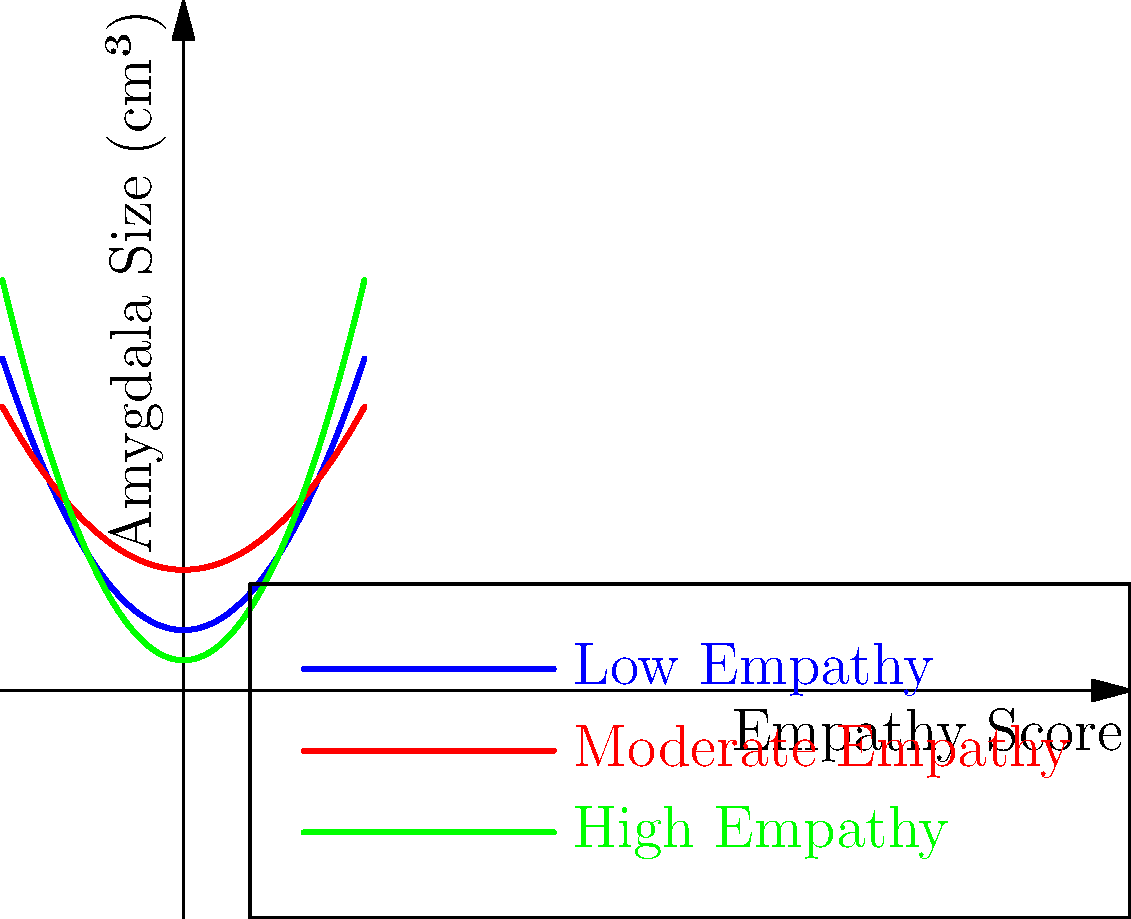Based on the graph showing the relationship between empathy scores and amygdala size for individuals with different levels of empathy, which of the following statements is most accurate regarding the structural differences in amygdala size across individuals with varying levels of empathy? To answer this question, we need to analyze the graph carefully:

1. The graph shows three curves representing the relationship between empathy scores and amygdala size for individuals with low, moderate, and high empathy.

2. The x-axis represents the empathy score, while the y-axis represents the amygdala size in cubic centimeters (cm³).

3. Observing the curves:
   a. The blue curve (low empathy) shows a moderate increase in amygdala size as empathy scores increase.
   b. The red curve (moderate empathy) shows a slower increase in amygdala size compared to the low empathy group.
   c. The green curve (high empathy) shows the steepest increase in amygdala size as empathy scores increase.

4. Comparing the curves:
   a. At lower empathy scores (left side of the graph), individuals with moderate empathy tend to have larger amygdala sizes compared to those with low or high empathy.
   b. As empathy scores increase, the amygdala size for highly empathetic individuals grows more rapidly than for the other two groups.
   c. At higher empathy scores (right side of the graph), individuals with high empathy tend to have the largest amygdala sizes.

5. The relationship between empathy and amygdala size is not linear for any group, as indicated by the curved lines.

6. The differences in amygdala size between the groups become more pronounced as empathy scores increase.

Based on these observations, we can conclude that there is a positive correlation between empathy scores and amygdala size, with the relationship being strongest for individuals with high empathy. The structural differences in amygdala size become more evident at higher levels of empathy.
Answer: Positive correlation between empathy and amygdala size, strongest in high-empathy individuals 